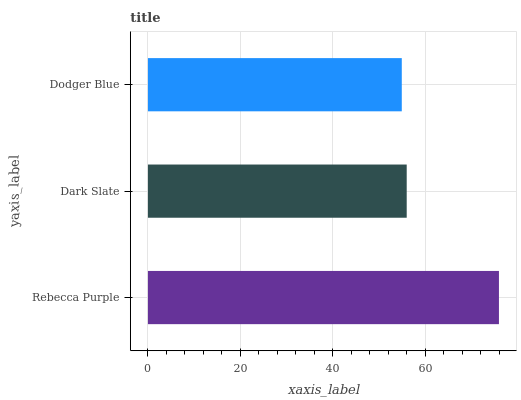Is Dodger Blue the minimum?
Answer yes or no. Yes. Is Rebecca Purple the maximum?
Answer yes or no. Yes. Is Dark Slate the minimum?
Answer yes or no. No. Is Dark Slate the maximum?
Answer yes or no. No. Is Rebecca Purple greater than Dark Slate?
Answer yes or no. Yes. Is Dark Slate less than Rebecca Purple?
Answer yes or no. Yes. Is Dark Slate greater than Rebecca Purple?
Answer yes or no. No. Is Rebecca Purple less than Dark Slate?
Answer yes or no. No. Is Dark Slate the high median?
Answer yes or no. Yes. Is Dark Slate the low median?
Answer yes or no. Yes. Is Rebecca Purple the high median?
Answer yes or no. No. Is Dodger Blue the low median?
Answer yes or no. No. 